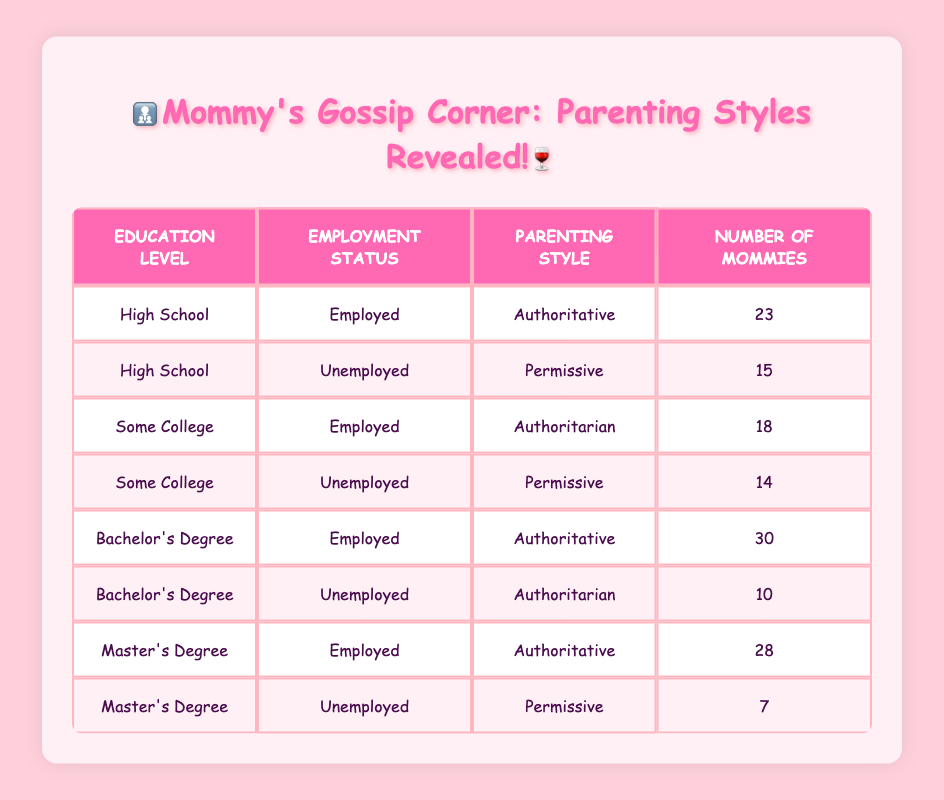What is the parenting style most associated with mothers who have a Bachelor's Degree and are employed? From the table, there is a row for mothers with a Bachelor's Degree and employed status that lists the parenting style as "Authoritative," with a count of 30 mothers.
Answer: Authoritative How many mothers who are unemployed and have a Master's Degree follow a Permissive parenting style? There is a specific entry in the table for mothers with a Master's Degree who are unemployed, and it shows that 7 mothers follow the Permissive parenting style.
Answer: 7 What is the total number of mothers who adopt an Authoritative parenting style? To find this total, we need to sum the counts of all mothers listed as Authoritative: (23 for High School employed) + (30 for Bachelor's Degree employed) + (28 for Master's Degree employed) = 81.
Answer: 81 Is it true that all mothers with a Master's Degree and unemployed prefer a Permissive parenting style? The table shows that there is only one entry for mothers with a Master's Degree who are unemployed, and it indicates they follow the Permissive parenting style. Hence, it’s true that this specific group prefers it.
Answer: Yes How many more mothers with a Bachelor's Degree are employed than those who are unemployed? From the table, 30 mothers with a Bachelor's Degree are employed, while 10 are unemployed. Thus, the difference is 30 - 10 = 20 mothers.
Answer: 20 What is the total number of mothers in the "Some College" category who have a Permissive parenting style? In the "Some College" category, there is only one entry that indicates that 14 mothers adopt a Permissive parenting style.
Answer: 14 Which employment status has the highest number of mothers practicing Authoritarian parenting across different education levels? The table shows two entries of Authoritarian parenting: 18 mothers who are employed and have Some College education and 10 mothers who are unemployed with a Bachelor's Degree. The sum of employed is higher (18) than unemployed (10), indicating employed mothers of Some College have the highest count.
Answer: Employed Do more mothers with only a High School education and employed status prefer Authoritative parenting compared to those who are unemployed? Yes, the table indicates that 23 employed mothers prefer Authoritative, while 15 unemployed mothers prefer Permissive, making it evident that employed mothers with High School education prefer Authoritative more.
Answer: Yes 